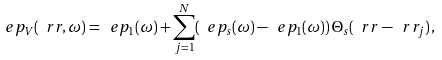Convert formula to latex. <formula><loc_0><loc_0><loc_500><loc_500>\ e p _ { V } ( \ r r , \omega ) = \ e p _ { 1 } ( \omega ) + \sum _ { j = 1 } ^ { N } ( \ e p _ { s } ( \omega ) - \ e p _ { 1 } ( \omega ) ) \, \Theta _ { s } ( \ r r - \ r r _ { j } ) \, ,</formula> 